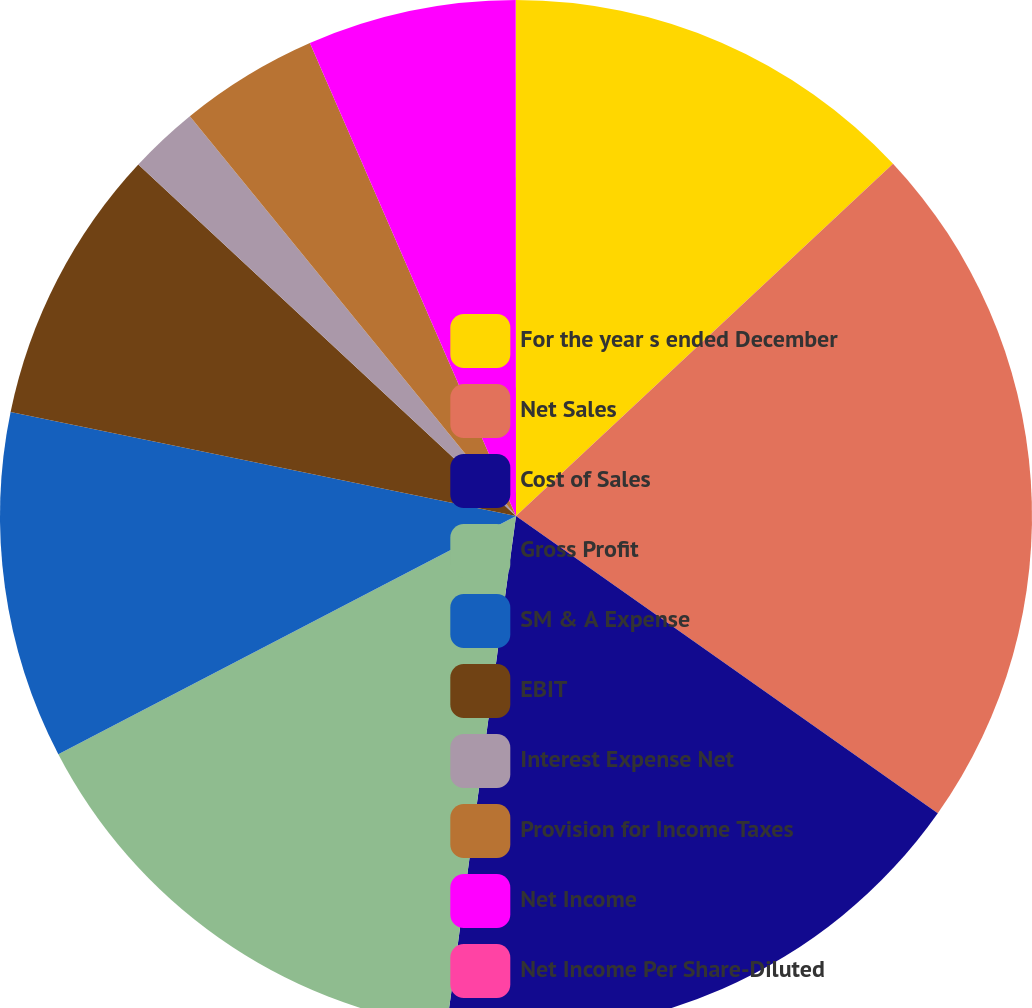Convert chart to OTSL. <chart><loc_0><loc_0><loc_500><loc_500><pie_chart><fcel>For the year s ended December<fcel>Net Sales<fcel>Cost of Sales<fcel>Gross Profit<fcel>SM & A Expense<fcel>EBIT<fcel>Interest Expense Net<fcel>Provision for Income Taxes<fcel>Net Income<fcel>Net Income Per Share-Diluted<nl><fcel>13.04%<fcel>21.73%<fcel>17.38%<fcel>15.21%<fcel>10.87%<fcel>8.7%<fcel>2.18%<fcel>4.35%<fcel>6.53%<fcel>0.01%<nl></chart> 